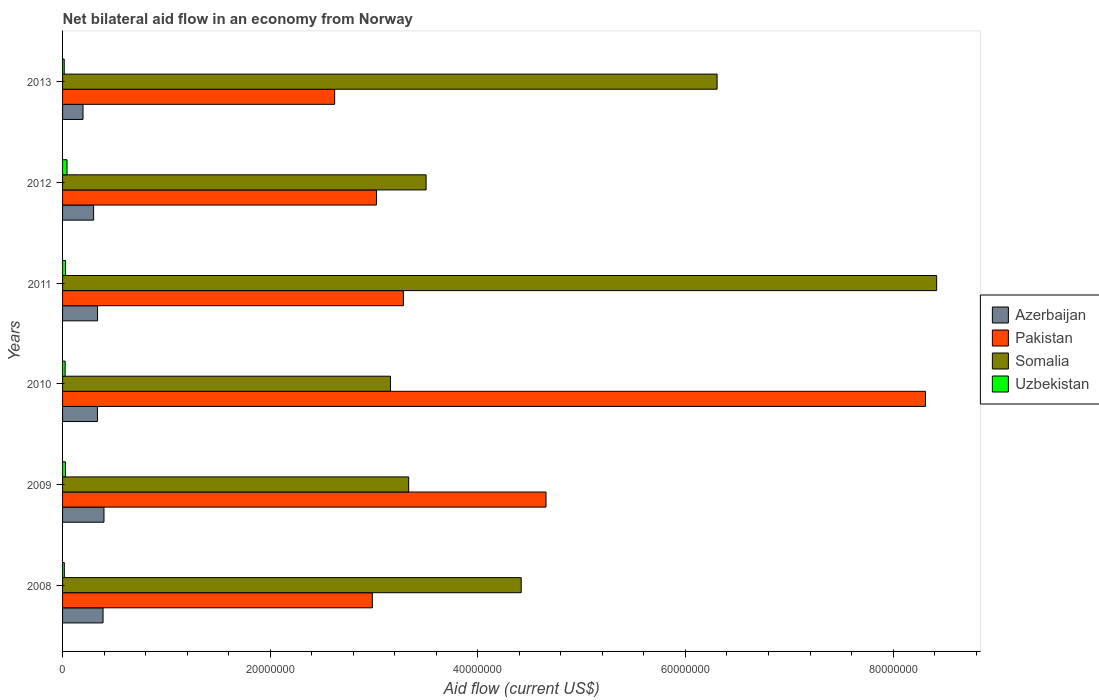Are the number of bars per tick equal to the number of legend labels?
Provide a short and direct response. Yes. What is the label of the 5th group of bars from the top?
Offer a very short reply. 2009. In how many cases, is the number of bars for a given year not equal to the number of legend labels?
Your answer should be compact. 0. Across all years, what is the maximum net bilateral aid flow in Uzbekistan?
Offer a very short reply. 4.30e+05. Across all years, what is the minimum net bilateral aid flow in Somalia?
Give a very brief answer. 3.16e+07. In which year was the net bilateral aid flow in Pakistan maximum?
Keep it short and to the point. 2010. What is the total net bilateral aid flow in Somalia in the graph?
Provide a succinct answer. 2.91e+08. What is the difference between the net bilateral aid flow in Uzbekistan in 2008 and that in 2013?
Keep it short and to the point. 10000. What is the difference between the net bilateral aid flow in Somalia in 2010 and the net bilateral aid flow in Azerbaijan in 2012?
Keep it short and to the point. 2.86e+07. What is the average net bilateral aid flow in Somalia per year?
Make the answer very short. 4.86e+07. In the year 2013, what is the difference between the net bilateral aid flow in Uzbekistan and net bilateral aid flow in Somalia?
Your response must be concise. -6.29e+07. In how many years, is the net bilateral aid flow in Pakistan greater than 36000000 US$?
Your answer should be very brief. 2. What is the ratio of the net bilateral aid flow in Azerbaijan in 2010 to that in 2011?
Offer a very short reply. 1. Is the net bilateral aid flow in Somalia in 2010 less than that in 2012?
Your answer should be compact. Yes. Is the difference between the net bilateral aid flow in Uzbekistan in 2008 and 2010 greater than the difference between the net bilateral aid flow in Somalia in 2008 and 2010?
Give a very brief answer. No. What is the difference between the highest and the second highest net bilateral aid flow in Pakistan?
Make the answer very short. 3.66e+07. What is the difference between the highest and the lowest net bilateral aid flow in Somalia?
Your answer should be very brief. 5.26e+07. In how many years, is the net bilateral aid flow in Somalia greater than the average net bilateral aid flow in Somalia taken over all years?
Ensure brevity in your answer.  2. What does the 1st bar from the top in 2011 represents?
Ensure brevity in your answer.  Uzbekistan. What does the 2nd bar from the bottom in 2011 represents?
Keep it short and to the point. Pakistan. How many bars are there?
Keep it short and to the point. 24. Are the values on the major ticks of X-axis written in scientific E-notation?
Your answer should be very brief. No. Does the graph contain grids?
Your answer should be compact. No. How many legend labels are there?
Make the answer very short. 4. What is the title of the graph?
Make the answer very short. Net bilateral aid flow in an economy from Norway. What is the label or title of the Y-axis?
Offer a very short reply. Years. What is the Aid flow (current US$) of Azerbaijan in 2008?
Your answer should be very brief. 3.90e+06. What is the Aid flow (current US$) of Pakistan in 2008?
Your answer should be very brief. 2.98e+07. What is the Aid flow (current US$) of Somalia in 2008?
Offer a terse response. 4.42e+07. What is the Aid flow (current US$) of Uzbekistan in 2008?
Ensure brevity in your answer.  1.70e+05. What is the Aid flow (current US$) of Azerbaijan in 2009?
Provide a succinct answer. 3.99e+06. What is the Aid flow (current US$) in Pakistan in 2009?
Provide a short and direct response. 4.66e+07. What is the Aid flow (current US$) of Somalia in 2009?
Provide a succinct answer. 3.33e+07. What is the Aid flow (current US$) of Uzbekistan in 2009?
Make the answer very short. 2.80e+05. What is the Aid flow (current US$) of Azerbaijan in 2010?
Your response must be concise. 3.36e+06. What is the Aid flow (current US$) of Pakistan in 2010?
Provide a succinct answer. 8.31e+07. What is the Aid flow (current US$) in Somalia in 2010?
Your answer should be compact. 3.16e+07. What is the Aid flow (current US$) in Azerbaijan in 2011?
Offer a very short reply. 3.37e+06. What is the Aid flow (current US$) of Pakistan in 2011?
Your response must be concise. 3.28e+07. What is the Aid flow (current US$) in Somalia in 2011?
Offer a terse response. 8.42e+07. What is the Aid flow (current US$) in Azerbaijan in 2012?
Your answer should be compact. 2.99e+06. What is the Aid flow (current US$) in Pakistan in 2012?
Keep it short and to the point. 3.02e+07. What is the Aid flow (current US$) of Somalia in 2012?
Keep it short and to the point. 3.50e+07. What is the Aid flow (current US$) of Uzbekistan in 2012?
Give a very brief answer. 4.30e+05. What is the Aid flow (current US$) of Azerbaijan in 2013?
Give a very brief answer. 1.97e+06. What is the Aid flow (current US$) in Pakistan in 2013?
Give a very brief answer. 2.62e+07. What is the Aid flow (current US$) in Somalia in 2013?
Ensure brevity in your answer.  6.30e+07. Across all years, what is the maximum Aid flow (current US$) in Azerbaijan?
Give a very brief answer. 3.99e+06. Across all years, what is the maximum Aid flow (current US$) in Pakistan?
Offer a very short reply. 8.31e+07. Across all years, what is the maximum Aid flow (current US$) of Somalia?
Provide a short and direct response. 8.42e+07. Across all years, what is the maximum Aid flow (current US$) in Uzbekistan?
Your response must be concise. 4.30e+05. Across all years, what is the minimum Aid flow (current US$) of Azerbaijan?
Provide a succinct answer. 1.97e+06. Across all years, what is the minimum Aid flow (current US$) of Pakistan?
Your answer should be compact. 2.62e+07. Across all years, what is the minimum Aid flow (current US$) of Somalia?
Ensure brevity in your answer.  3.16e+07. Across all years, what is the minimum Aid flow (current US$) in Uzbekistan?
Provide a short and direct response. 1.60e+05. What is the total Aid flow (current US$) in Azerbaijan in the graph?
Give a very brief answer. 1.96e+07. What is the total Aid flow (current US$) of Pakistan in the graph?
Your answer should be compact. 2.49e+08. What is the total Aid flow (current US$) in Somalia in the graph?
Keep it short and to the point. 2.91e+08. What is the total Aid flow (current US$) of Uzbekistan in the graph?
Offer a very short reply. 1.58e+06. What is the difference between the Aid flow (current US$) in Pakistan in 2008 and that in 2009?
Ensure brevity in your answer.  -1.67e+07. What is the difference between the Aid flow (current US$) in Somalia in 2008 and that in 2009?
Keep it short and to the point. 1.08e+07. What is the difference between the Aid flow (current US$) in Azerbaijan in 2008 and that in 2010?
Provide a succinct answer. 5.40e+05. What is the difference between the Aid flow (current US$) of Pakistan in 2008 and that in 2010?
Provide a succinct answer. -5.33e+07. What is the difference between the Aid flow (current US$) of Somalia in 2008 and that in 2010?
Give a very brief answer. 1.26e+07. What is the difference between the Aid flow (current US$) of Azerbaijan in 2008 and that in 2011?
Provide a short and direct response. 5.30e+05. What is the difference between the Aid flow (current US$) of Pakistan in 2008 and that in 2011?
Provide a succinct answer. -2.99e+06. What is the difference between the Aid flow (current US$) of Somalia in 2008 and that in 2011?
Give a very brief answer. -4.00e+07. What is the difference between the Aid flow (current US$) of Azerbaijan in 2008 and that in 2012?
Make the answer very short. 9.10e+05. What is the difference between the Aid flow (current US$) of Pakistan in 2008 and that in 2012?
Give a very brief answer. -4.00e+05. What is the difference between the Aid flow (current US$) of Somalia in 2008 and that in 2012?
Make the answer very short. 9.16e+06. What is the difference between the Aid flow (current US$) of Uzbekistan in 2008 and that in 2012?
Keep it short and to the point. -2.60e+05. What is the difference between the Aid flow (current US$) of Azerbaijan in 2008 and that in 2013?
Ensure brevity in your answer.  1.93e+06. What is the difference between the Aid flow (current US$) in Pakistan in 2008 and that in 2013?
Keep it short and to the point. 3.63e+06. What is the difference between the Aid flow (current US$) of Somalia in 2008 and that in 2013?
Your response must be concise. -1.89e+07. What is the difference between the Aid flow (current US$) of Uzbekistan in 2008 and that in 2013?
Provide a short and direct response. 10000. What is the difference between the Aid flow (current US$) of Azerbaijan in 2009 and that in 2010?
Provide a short and direct response. 6.30e+05. What is the difference between the Aid flow (current US$) of Pakistan in 2009 and that in 2010?
Keep it short and to the point. -3.66e+07. What is the difference between the Aid flow (current US$) of Somalia in 2009 and that in 2010?
Make the answer very short. 1.75e+06. What is the difference between the Aid flow (current US$) in Uzbekistan in 2009 and that in 2010?
Make the answer very short. 3.00e+04. What is the difference between the Aid flow (current US$) in Azerbaijan in 2009 and that in 2011?
Give a very brief answer. 6.20e+05. What is the difference between the Aid flow (current US$) of Pakistan in 2009 and that in 2011?
Offer a terse response. 1.37e+07. What is the difference between the Aid flow (current US$) of Somalia in 2009 and that in 2011?
Keep it short and to the point. -5.09e+07. What is the difference between the Aid flow (current US$) in Azerbaijan in 2009 and that in 2012?
Offer a very short reply. 1.00e+06. What is the difference between the Aid flow (current US$) of Pakistan in 2009 and that in 2012?
Give a very brief answer. 1.63e+07. What is the difference between the Aid flow (current US$) in Somalia in 2009 and that in 2012?
Make the answer very short. -1.68e+06. What is the difference between the Aid flow (current US$) of Azerbaijan in 2009 and that in 2013?
Your answer should be compact. 2.02e+06. What is the difference between the Aid flow (current US$) of Pakistan in 2009 and that in 2013?
Your response must be concise. 2.04e+07. What is the difference between the Aid flow (current US$) in Somalia in 2009 and that in 2013?
Offer a terse response. -2.97e+07. What is the difference between the Aid flow (current US$) of Pakistan in 2010 and that in 2011?
Provide a short and direct response. 5.03e+07. What is the difference between the Aid flow (current US$) in Somalia in 2010 and that in 2011?
Give a very brief answer. -5.26e+07. What is the difference between the Aid flow (current US$) of Uzbekistan in 2010 and that in 2011?
Ensure brevity in your answer.  -4.00e+04. What is the difference between the Aid flow (current US$) of Azerbaijan in 2010 and that in 2012?
Keep it short and to the point. 3.70e+05. What is the difference between the Aid flow (current US$) of Pakistan in 2010 and that in 2012?
Make the answer very short. 5.29e+07. What is the difference between the Aid flow (current US$) of Somalia in 2010 and that in 2012?
Your answer should be very brief. -3.43e+06. What is the difference between the Aid flow (current US$) in Uzbekistan in 2010 and that in 2012?
Keep it short and to the point. -1.80e+05. What is the difference between the Aid flow (current US$) of Azerbaijan in 2010 and that in 2013?
Provide a succinct answer. 1.39e+06. What is the difference between the Aid flow (current US$) of Pakistan in 2010 and that in 2013?
Make the answer very short. 5.69e+07. What is the difference between the Aid flow (current US$) in Somalia in 2010 and that in 2013?
Your answer should be compact. -3.15e+07. What is the difference between the Aid flow (current US$) in Azerbaijan in 2011 and that in 2012?
Keep it short and to the point. 3.80e+05. What is the difference between the Aid flow (current US$) of Pakistan in 2011 and that in 2012?
Keep it short and to the point. 2.59e+06. What is the difference between the Aid flow (current US$) of Somalia in 2011 and that in 2012?
Make the answer very short. 4.92e+07. What is the difference between the Aid flow (current US$) in Uzbekistan in 2011 and that in 2012?
Provide a short and direct response. -1.40e+05. What is the difference between the Aid flow (current US$) in Azerbaijan in 2011 and that in 2013?
Provide a short and direct response. 1.40e+06. What is the difference between the Aid flow (current US$) of Pakistan in 2011 and that in 2013?
Make the answer very short. 6.62e+06. What is the difference between the Aid flow (current US$) of Somalia in 2011 and that in 2013?
Make the answer very short. 2.12e+07. What is the difference between the Aid flow (current US$) in Uzbekistan in 2011 and that in 2013?
Your response must be concise. 1.30e+05. What is the difference between the Aid flow (current US$) in Azerbaijan in 2012 and that in 2013?
Ensure brevity in your answer.  1.02e+06. What is the difference between the Aid flow (current US$) in Pakistan in 2012 and that in 2013?
Offer a very short reply. 4.03e+06. What is the difference between the Aid flow (current US$) in Somalia in 2012 and that in 2013?
Offer a terse response. -2.80e+07. What is the difference between the Aid flow (current US$) of Uzbekistan in 2012 and that in 2013?
Your answer should be very brief. 2.70e+05. What is the difference between the Aid flow (current US$) in Azerbaijan in 2008 and the Aid flow (current US$) in Pakistan in 2009?
Offer a terse response. -4.27e+07. What is the difference between the Aid flow (current US$) in Azerbaijan in 2008 and the Aid flow (current US$) in Somalia in 2009?
Make the answer very short. -2.94e+07. What is the difference between the Aid flow (current US$) in Azerbaijan in 2008 and the Aid flow (current US$) in Uzbekistan in 2009?
Keep it short and to the point. 3.62e+06. What is the difference between the Aid flow (current US$) of Pakistan in 2008 and the Aid flow (current US$) of Somalia in 2009?
Provide a succinct answer. -3.50e+06. What is the difference between the Aid flow (current US$) of Pakistan in 2008 and the Aid flow (current US$) of Uzbekistan in 2009?
Make the answer very short. 2.96e+07. What is the difference between the Aid flow (current US$) of Somalia in 2008 and the Aid flow (current US$) of Uzbekistan in 2009?
Give a very brief answer. 4.39e+07. What is the difference between the Aid flow (current US$) in Azerbaijan in 2008 and the Aid flow (current US$) in Pakistan in 2010?
Give a very brief answer. -7.92e+07. What is the difference between the Aid flow (current US$) of Azerbaijan in 2008 and the Aid flow (current US$) of Somalia in 2010?
Keep it short and to the point. -2.77e+07. What is the difference between the Aid flow (current US$) in Azerbaijan in 2008 and the Aid flow (current US$) in Uzbekistan in 2010?
Provide a succinct answer. 3.65e+06. What is the difference between the Aid flow (current US$) of Pakistan in 2008 and the Aid flow (current US$) of Somalia in 2010?
Offer a terse response. -1.75e+06. What is the difference between the Aid flow (current US$) of Pakistan in 2008 and the Aid flow (current US$) of Uzbekistan in 2010?
Provide a succinct answer. 2.96e+07. What is the difference between the Aid flow (current US$) in Somalia in 2008 and the Aid flow (current US$) in Uzbekistan in 2010?
Your answer should be very brief. 4.39e+07. What is the difference between the Aid flow (current US$) of Azerbaijan in 2008 and the Aid flow (current US$) of Pakistan in 2011?
Your answer should be compact. -2.89e+07. What is the difference between the Aid flow (current US$) in Azerbaijan in 2008 and the Aid flow (current US$) in Somalia in 2011?
Your response must be concise. -8.03e+07. What is the difference between the Aid flow (current US$) of Azerbaijan in 2008 and the Aid flow (current US$) of Uzbekistan in 2011?
Offer a very short reply. 3.61e+06. What is the difference between the Aid flow (current US$) of Pakistan in 2008 and the Aid flow (current US$) of Somalia in 2011?
Keep it short and to the point. -5.44e+07. What is the difference between the Aid flow (current US$) of Pakistan in 2008 and the Aid flow (current US$) of Uzbekistan in 2011?
Make the answer very short. 2.96e+07. What is the difference between the Aid flow (current US$) of Somalia in 2008 and the Aid flow (current US$) of Uzbekistan in 2011?
Offer a very short reply. 4.39e+07. What is the difference between the Aid flow (current US$) of Azerbaijan in 2008 and the Aid flow (current US$) of Pakistan in 2012?
Ensure brevity in your answer.  -2.63e+07. What is the difference between the Aid flow (current US$) in Azerbaijan in 2008 and the Aid flow (current US$) in Somalia in 2012?
Offer a very short reply. -3.11e+07. What is the difference between the Aid flow (current US$) in Azerbaijan in 2008 and the Aid flow (current US$) in Uzbekistan in 2012?
Keep it short and to the point. 3.47e+06. What is the difference between the Aid flow (current US$) of Pakistan in 2008 and the Aid flow (current US$) of Somalia in 2012?
Make the answer very short. -5.18e+06. What is the difference between the Aid flow (current US$) in Pakistan in 2008 and the Aid flow (current US$) in Uzbekistan in 2012?
Make the answer very short. 2.94e+07. What is the difference between the Aid flow (current US$) in Somalia in 2008 and the Aid flow (current US$) in Uzbekistan in 2012?
Offer a terse response. 4.38e+07. What is the difference between the Aid flow (current US$) of Azerbaijan in 2008 and the Aid flow (current US$) of Pakistan in 2013?
Provide a short and direct response. -2.23e+07. What is the difference between the Aid flow (current US$) of Azerbaijan in 2008 and the Aid flow (current US$) of Somalia in 2013?
Keep it short and to the point. -5.92e+07. What is the difference between the Aid flow (current US$) in Azerbaijan in 2008 and the Aid flow (current US$) in Uzbekistan in 2013?
Offer a terse response. 3.74e+06. What is the difference between the Aid flow (current US$) in Pakistan in 2008 and the Aid flow (current US$) in Somalia in 2013?
Give a very brief answer. -3.32e+07. What is the difference between the Aid flow (current US$) of Pakistan in 2008 and the Aid flow (current US$) of Uzbekistan in 2013?
Provide a succinct answer. 2.97e+07. What is the difference between the Aid flow (current US$) in Somalia in 2008 and the Aid flow (current US$) in Uzbekistan in 2013?
Your response must be concise. 4.40e+07. What is the difference between the Aid flow (current US$) of Azerbaijan in 2009 and the Aid flow (current US$) of Pakistan in 2010?
Keep it short and to the point. -7.91e+07. What is the difference between the Aid flow (current US$) in Azerbaijan in 2009 and the Aid flow (current US$) in Somalia in 2010?
Make the answer very short. -2.76e+07. What is the difference between the Aid flow (current US$) in Azerbaijan in 2009 and the Aid flow (current US$) in Uzbekistan in 2010?
Make the answer very short. 3.74e+06. What is the difference between the Aid flow (current US$) in Pakistan in 2009 and the Aid flow (current US$) in Somalia in 2010?
Provide a short and direct response. 1.50e+07. What is the difference between the Aid flow (current US$) in Pakistan in 2009 and the Aid flow (current US$) in Uzbekistan in 2010?
Offer a very short reply. 4.63e+07. What is the difference between the Aid flow (current US$) of Somalia in 2009 and the Aid flow (current US$) of Uzbekistan in 2010?
Keep it short and to the point. 3.31e+07. What is the difference between the Aid flow (current US$) of Azerbaijan in 2009 and the Aid flow (current US$) of Pakistan in 2011?
Offer a terse response. -2.88e+07. What is the difference between the Aid flow (current US$) in Azerbaijan in 2009 and the Aid flow (current US$) in Somalia in 2011?
Your answer should be very brief. -8.02e+07. What is the difference between the Aid flow (current US$) in Azerbaijan in 2009 and the Aid flow (current US$) in Uzbekistan in 2011?
Ensure brevity in your answer.  3.70e+06. What is the difference between the Aid flow (current US$) in Pakistan in 2009 and the Aid flow (current US$) in Somalia in 2011?
Offer a very short reply. -3.76e+07. What is the difference between the Aid flow (current US$) of Pakistan in 2009 and the Aid flow (current US$) of Uzbekistan in 2011?
Offer a terse response. 4.63e+07. What is the difference between the Aid flow (current US$) of Somalia in 2009 and the Aid flow (current US$) of Uzbekistan in 2011?
Provide a succinct answer. 3.30e+07. What is the difference between the Aid flow (current US$) in Azerbaijan in 2009 and the Aid flow (current US$) in Pakistan in 2012?
Give a very brief answer. -2.62e+07. What is the difference between the Aid flow (current US$) of Azerbaijan in 2009 and the Aid flow (current US$) of Somalia in 2012?
Ensure brevity in your answer.  -3.10e+07. What is the difference between the Aid flow (current US$) of Azerbaijan in 2009 and the Aid flow (current US$) of Uzbekistan in 2012?
Offer a terse response. 3.56e+06. What is the difference between the Aid flow (current US$) in Pakistan in 2009 and the Aid flow (current US$) in Somalia in 2012?
Make the answer very short. 1.16e+07. What is the difference between the Aid flow (current US$) of Pakistan in 2009 and the Aid flow (current US$) of Uzbekistan in 2012?
Offer a terse response. 4.61e+07. What is the difference between the Aid flow (current US$) of Somalia in 2009 and the Aid flow (current US$) of Uzbekistan in 2012?
Provide a succinct answer. 3.29e+07. What is the difference between the Aid flow (current US$) in Azerbaijan in 2009 and the Aid flow (current US$) in Pakistan in 2013?
Your answer should be very brief. -2.22e+07. What is the difference between the Aid flow (current US$) of Azerbaijan in 2009 and the Aid flow (current US$) of Somalia in 2013?
Ensure brevity in your answer.  -5.91e+07. What is the difference between the Aid flow (current US$) in Azerbaijan in 2009 and the Aid flow (current US$) in Uzbekistan in 2013?
Provide a succinct answer. 3.83e+06. What is the difference between the Aid flow (current US$) in Pakistan in 2009 and the Aid flow (current US$) in Somalia in 2013?
Your answer should be very brief. -1.65e+07. What is the difference between the Aid flow (current US$) of Pakistan in 2009 and the Aid flow (current US$) of Uzbekistan in 2013?
Ensure brevity in your answer.  4.64e+07. What is the difference between the Aid flow (current US$) in Somalia in 2009 and the Aid flow (current US$) in Uzbekistan in 2013?
Ensure brevity in your answer.  3.32e+07. What is the difference between the Aid flow (current US$) of Azerbaijan in 2010 and the Aid flow (current US$) of Pakistan in 2011?
Offer a very short reply. -2.95e+07. What is the difference between the Aid flow (current US$) in Azerbaijan in 2010 and the Aid flow (current US$) in Somalia in 2011?
Ensure brevity in your answer.  -8.08e+07. What is the difference between the Aid flow (current US$) in Azerbaijan in 2010 and the Aid flow (current US$) in Uzbekistan in 2011?
Provide a succinct answer. 3.07e+06. What is the difference between the Aid flow (current US$) of Pakistan in 2010 and the Aid flow (current US$) of Somalia in 2011?
Provide a succinct answer. -1.08e+06. What is the difference between the Aid flow (current US$) of Pakistan in 2010 and the Aid flow (current US$) of Uzbekistan in 2011?
Provide a short and direct response. 8.28e+07. What is the difference between the Aid flow (current US$) in Somalia in 2010 and the Aid flow (current US$) in Uzbekistan in 2011?
Give a very brief answer. 3.13e+07. What is the difference between the Aid flow (current US$) of Azerbaijan in 2010 and the Aid flow (current US$) of Pakistan in 2012?
Make the answer very short. -2.69e+07. What is the difference between the Aid flow (current US$) of Azerbaijan in 2010 and the Aid flow (current US$) of Somalia in 2012?
Provide a short and direct response. -3.17e+07. What is the difference between the Aid flow (current US$) of Azerbaijan in 2010 and the Aid flow (current US$) of Uzbekistan in 2012?
Offer a very short reply. 2.93e+06. What is the difference between the Aid flow (current US$) in Pakistan in 2010 and the Aid flow (current US$) in Somalia in 2012?
Your response must be concise. 4.81e+07. What is the difference between the Aid flow (current US$) in Pakistan in 2010 and the Aid flow (current US$) in Uzbekistan in 2012?
Your response must be concise. 8.27e+07. What is the difference between the Aid flow (current US$) in Somalia in 2010 and the Aid flow (current US$) in Uzbekistan in 2012?
Your response must be concise. 3.12e+07. What is the difference between the Aid flow (current US$) in Azerbaijan in 2010 and the Aid flow (current US$) in Pakistan in 2013?
Give a very brief answer. -2.28e+07. What is the difference between the Aid flow (current US$) of Azerbaijan in 2010 and the Aid flow (current US$) of Somalia in 2013?
Offer a terse response. -5.97e+07. What is the difference between the Aid flow (current US$) in Azerbaijan in 2010 and the Aid flow (current US$) in Uzbekistan in 2013?
Your answer should be compact. 3.20e+06. What is the difference between the Aid flow (current US$) in Pakistan in 2010 and the Aid flow (current US$) in Somalia in 2013?
Provide a succinct answer. 2.01e+07. What is the difference between the Aid flow (current US$) of Pakistan in 2010 and the Aid flow (current US$) of Uzbekistan in 2013?
Ensure brevity in your answer.  8.30e+07. What is the difference between the Aid flow (current US$) of Somalia in 2010 and the Aid flow (current US$) of Uzbekistan in 2013?
Offer a terse response. 3.14e+07. What is the difference between the Aid flow (current US$) in Azerbaijan in 2011 and the Aid flow (current US$) in Pakistan in 2012?
Your response must be concise. -2.69e+07. What is the difference between the Aid flow (current US$) of Azerbaijan in 2011 and the Aid flow (current US$) of Somalia in 2012?
Offer a terse response. -3.16e+07. What is the difference between the Aid flow (current US$) of Azerbaijan in 2011 and the Aid flow (current US$) of Uzbekistan in 2012?
Make the answer very short. 2.94e+06. What is the difference between the Aid flow (current US$) of Pakistan in 2011 and the Aid flow (current US$) of Somalia in 2012?
Your response must be concise. -2.19e+06. What is the difference between the Aid flow (current US$) in Pakistan in 2011 and the Aid flow (current US$) in Uzbekistan in 2012?
Provide a succinct answer. 3.24e+07. What is the difference between the Aid flow (current US$) in Somalia in 2011 and the Aid flow (current US$) in Uzbekistan in 2012?
Make the answer very short. 8.38e+07. What is the difference between the Aid flow (current US$) in Azerbaijan in 2011 and the Aid flow (current US$) in Pakistan in 2013?
Your response must be concise. -2.28e+07. What is the difference between the Aid flow (current US$) in Azerbaijan in 2011 and the Aid flow (current US$) in Somalia in 2013?
Give a very brief answer. -5.97e+07. What is the difference between the Aid flow (current US$) of Azerbaijan in 2011 and the Aid flow (current US$) of Uzbekistan in 2013?
Ensure brevity in your answer.  3.21e+06. What is the difference between the Aid flow (current US$) of Pakistan in 2011 and the Aid flow (current US$) of Somalia in 2013?
Your response must be concise. -3.02e+07. What is the difference between the Aid flow (current US$) in Pakistan in 2011 and the Aid flow (current US$) in Uzbekistan in 2013?
Give a very brief answer. 3.27e+07. What is the difference between the Aid flow (current US$) of Somalia in 2011 and the Aid flow (current US$) of Uzbekistan in 2013?
Ensure brevity in your answer.  8.40e+07. What is the difference between the Aid flow (current US$) of Azerbaijan in 2012 and the Aid flow (current US$) of Pakistan in 2013?
Offer a terse response. -2.32e+07. What is the difference between the Aid flow (current US$) of Azerbaijan in 2012 and the Aid flow (current US$) of Somalia in 2013?
Provide a succinct answer. -6.01e+07. What is the difference between the Aid flow (current US$) of Azerbaijan in 2012 and the Aid flow (current US$) of Uzbekistan in 2013?
Provide a short and direct response. 2.83e+06. What is the difference between the Aid flow (current US$) in Pakistan in 2012 and the Aid flow (current US$) in Somalia in 2013?
Offer a terse response. -3.28e+07. What is the difference between the Aid flow (current US$) in Pakistan in 2012 and the Aid flow (current US$) in Uzbekistan in 2013?
Keep it short and to the point. 3.01e+07. What is the difference between the Aid flow (current US$) of Somalia in 2012 and the Aid flow (current US$) of Uzbekistan in 2013?
Give a very brief answer. 3.49e+07. What is the average Aid flow (current US$) of Azerbaijan per year?
Provide a short and direct response. 3.26e+06. What is the average Aid flow (current US$) in Pakistan per year?
Offer a very short reply. 4.15e+07. What is the average Aid flow (current US$) in Somalia per year?
Provide a short and direct response. 4.86e+07. What is the average Aid flow (current US$) of Uzbekistan per year?
Your response must be concise. 2.63e+05. In the year 2008, what is the difference between the Aid flow (current US$) in Azerbaijan and Aid flow (current US$) in Pakistan?
Make the answer very short. -2.59e+07. In the year 2008, what is the difference between the Aid flow (current US$) in Azerbaijan and Aid flow (current US$) in Somalia?
Provide a succinct answer. -4.03e+07. In the year 2008, what is the difference between the Aid flow (current US$) of Azerbaijan and Aid flow (current US$) of Uzbekistan?
Make the answer very short. 3.73e+06. In the year 2008, what is the difference between the Aid flow (current US$) of Pakistan and Aid flow (current US$) of Somalia?
Provide a short and direct response. -1.43e+07. In the year 2008, what is the difference between the Aid flow (current US$) in Pakistan and Aid flow (current US$) in Uzbekistan?
Keep it short and to the point. 2.97e+07. In the year 2008, what is the difference between the Aid flow (current US$) in Somalia and Aid flow (current US$) in Uzbekistan?
Ensure brevity in your answer.  4.40e+07. In the year 2009, what is the difference between the Aid flow (current US$) of Azerbaijan and Aid flow (current US$) of Pakistan?
Ensure brevity in your answer.  -4.26e+07. In the year 2009, what is the difference between the Aid flow (current US$) in Azerbaijan and Aid flow (current US$) in Somalia?
Provide a short and direct response. -2.94e+07. In the year 2009, what is the difference between the Aid flow (current US$) of Azerbaijan and Aid flow (current US$) of Uzbekistan?
Your response must be concise. 3.71e+06. In the year 2009, what is the difference between the Aid flow (current US$) of Pakistan and Aid flow (current US$) of Somalia?
Make the answer very short. 1.32e+07. In the year 2009, what is the difference between the Aid flow (current US$) in Pakistan and Aid flow (current US$) in Uzbekistan?
Offer a very short reply. 4.63e+07. In the year 2009, what is the difference between the Aid flow (current US$) in Somalia and Aid flow (current US$) in Uzbekistan?
Offer a terse response. 3.31e+07. In the year 2010, what is the difference between the Aid flow (current US$) in Azerbaijan and Aid flow (current US$) in Pakistan?
Ensure brevity in your answer.  -7.98e+07. In the year 2010, what is the difference between the Aid flow (current US$) of Azerbaijan and Aid flow (current US$) of Somalia?
Provide a succinct answer. -2.82e+07. In the year 2010, what is the difference between the Aid flow (current US$) of Azerbaijan and Aid flow (current US$) of Uzbekistan?
Make the answer very short. 3.11e+06. In the year 2010, what is the difference between the Aid flow (current US$) of Pakistan and Aid flow (current US$) of Somalia?
Offer a very short reply. 5.15e+07. In the year 2010, what is the difference between the Aid flow (current US$) of Pakistan and Aid flow (current US$) of Uzbekistan?
Provide a short and direct response. 8.29e+07. In the year 2010, what is the difference between the Aid flow (current US$) in Somalia and Aid flow (current US$) in Uzbekistan?
Your response must be concise. 3.13e+07. In the year 2011, what is the difference between the Aid flow (current US$) of Azerbaijan and Aid flow (current US$) of Pakistan?
Offer a very short reply. -2.95e+07. In the year 2011, what is the difference between the Aid flow (current US$) of Azerbaijan and Aid flow (current US$) of Somalia?
Offer a very short reply. -8.08e+07. In the year 2011, what is the difference between the Aid flow (current US$) of Azerbaijan and Aid flow (current US$) of Uzbekistan?
Offer a very short reply. 3.08e+06. In the year 2011, what is the difference between the Aid flow (current US$) in Pakistan and Aid flow (current US$) in Somalia?
Offer a very short reply. -5.14e+07. In the year 2011, what is the difference between the Aid flow (current US$) of Pakistan and Aid flow (current US$) of Uzbekistan?
Give a very brief answer. 3.25e+07. In the year 2011, what is the difference between the Aid flow (current US$) in Somalia and Aid flow (current US$) in Uzbekistan?
Your answer should be compact. 8.39e+07. In the year 2012, what is the difference between the Aid flow (current US$) in Azerbaijan and Aid flow (current US$) in Pakistan?
Ensure brevity in your answer.  -2.72e+07. In the year 2012, what is the difference between the Aid flow (current US$) of Azerbaijan and Aid flow (current US$) of Somalia?
Your response must be concise. -3.20e+07. In the year 2012, what is the difference between the Aid flow (current US$) of Azerbaijan and Aid flow (current US$) of Uzbekistan?
Provide a short and direct response. 2.56e+06. In the year 2012, what is the difference between the Aid flow (current US$) in Pakistan and Aid flow (current US$) in Somalia?
Offer a terse response. -4.78e+06. In the year 2012, what is the difference between the Aid flow (current US$) of Pakistan and Aid flow (current US$) of Uzbekistan?
Provide a succinct answer. 2.98e+07. In the year 2012, what is the difference between the Aid flow (current US$) in Somalia and Aid flow (current US$) in Uzbekistan?
Provide a short and direct response. 3.46e+07. In the year 2013, what is the difference between the Aid flow (current US$) in Azerbaijan and Aid flow (current US$) in Pakistan?
Give a very brief answer. -2.42e+07. In the year 2013, what is the difference between the Aid flow (current US$) of Azerbaijan and Aid flow (current US$) of Somalia?
Offer a very short reply. -6.11e+07. In the year 2013, what is the difference between the Aid flow (current US$) of Azerbaijan and Aid flow (current US$) of Uzbekistan?
Ensure brevity in your answer.  1.81e+06. In the year 2013, what is the difference between the Aid flow (current US$) in Pakistan and Aid flow (current US$) in Somalia?
Make the answer very short. -3.68e+07. In the year 2013, what is the difference between the Aid flow (current US$) of Pakistan and Aid flow (current US$) of Uzbekistan?
Offer a terse response. 2.60e+07. In the year 2013, what is the difference between the Aid flow (current US$) of Somalia and Aid flow (current US$) of Uzbekistan?
Offer a very short reply. 6.29e+07. What is the ratio of the Aid flow (current US$) in Azerbaijan in 2008 to that in 2009?
Provide a short and direct response. 0.98. What is the ratio of the Aid flow (current US$) of Pakistan in 2008 to that in 2009?
Your answer should be compact. 0.64. What is the ratio of the Aid flow (current US$) in Somalia in 2008 to that in 2009?
Your response must be concise. 1.33. What is the ratio of the Aid flow (current US$) in Uzbekistan in 2008 to that in 2009?
Ensure brevity in your answer.  0.61. What is the ratio of the Aid flow (current US$) of Azerbaijan in 2008 to that in 2010?
Keep it short and to the point. 1.16. What is the ratio of the Aid flow (current US$) in Pakistan in 2008 to that in 2010?
Give a very brief answer. 0.36. What is the ratio of the Aid flow (current US$) in Somalia in 2008 to that in 2010?
Keep it short and to the point. 1.4. What is the ratio of the Aid flow (current US$) in Uzbekistan in 2008 to that in 2010?
Give a very brief answer. 0.68. What is the ratio of the Aid flow (current US$) in Azerbaijan in 2008 to that in 2011?
Your response must be concise. 1.16. What is the ratio of the Aid flow (current US$) of Pakistan in 2008 to that in 2011?
Make the answer very short. 0.91. What is the ratio of the Aid flow (current US$) of Somalia in 2008 to that in 2011?
Give a very brief answer. 0.52. What is the ratio of the Aid flow (current US$) in Uzbekistan in 2008 to that in 2011?
Provide a short and direct response. 0.59. What is the ratio of the Aid flow (current US$) in Azerbaijan in 2008 to that in 2012?
Your answer should be compact. 1.3. What is the ratio of the Aid flow (current US$) of Somalia in 2008 to that in 2012?
Keep it short and to the point. 1.26. What is the ratio of the Aid flow (current US$) in Uzbekistan in 2008 to that in 2012?
Provide a succinct answer. 0.4. What is the ratio of the Aid flow (current US$) of Azerbaijan in 2008 to that in 2013?
Your answer should be very brief. 1.98. What is the ratio of the Aid flow (current US$) in Pakistan in 2008 to that in 2013?
Your answer should be very brief. 1.14. What is the ratio of the Aid flow (current US$) of Somalia in 2008 to that in 2013?
Ensure brevity in your answer.  0.7. What is the ratio of the Aid flow (current US$) of Uzbekistan in 2008 to that in 2013?
Provide a succinct answer. 1.06. What is the ratio of the Aid flow (current US$) of Azerbaijan in 2009 to that in 2010?
Your response must be concise. 1.19. What is the ratio of the Aid flow (current US$) of Pakistan in 2009 to that in 2010?
Keep it short and to the point. 0.56. What is the ratio of the Aid flow (current US$) of Somalia in 2009 to that in 2010?
Ensure brevity in your answer.  1.06. What is the ratio of the Aid flow (current US$) in Uzbekistan in 2009 to that in 2010?
Make the answer very short. 1.12. What is the ratio of the Aid flow (current US$) of Azerbaijan in 2009 to that in 2011?
Provide a succinct answer. 1.18. What is the ratio of the Aid flow (current US$) in Pakistan in 2009 to that in 2011?
Provide a succinct answer. 1.42. What is the ratio of the Aid flow (current US$) of Somalia in 2009 to that in 2011?
Your answer should be very brief. 0.4. What is the ratio of the Aid flow (current US$) of Uzbekistan in 2009 to that in 2011?
Your answer should be very brief. 0.97. What is the ratio of the Aid flow (current US$) of Azerbaijan in 2009 to that in 2012?
Give a very brief answer. 1.33. What is the ratio of the Aid flow (current US$) of Pakistan in 2009 to that in 2012?
Keep it short and to the point. 1.54. What is the ratio of the Aid flow (current US$) in Uzbekistan in 2009 to that in 2012?
Offer a terse response. 0.65. What is the ratio of the Aid flow (current US$) in Azerbaijan in 2009 to that in 2013?
Keep it short and to the point. 2.03. What is the ratio of the Aid flow (current US$) in Pakistan in 2009 to that in 2013?
Give a very brief answer. 1.78. What is the ratio of the Aid flow (current US$) in Somalia in 2009 to that in 2013?
Provide a short and direct response. 0.53. What is the ratio of the Aid flow (current US$) in Pakistan in 2010 to that in 2011?
Give a very brief answer. 2.53. What is the ratio of the Aid flow (current US$) of Somalia in 2010 to that in 2011?
Give a very brief answer. 0.38. What is the ratio of the Aid flow (current US$) of Uzbekistan in 2010 to that in 2011?
Ensure brevity in your answer.  0.86. What is the ratio of the Aid flow (current US$) in Azerbaijan in 2010 to that in 2012?
Offer a terse response. 1.12. What is the ratio of the Aid flow (current US$) of Pakistan in 2010 to that in 2012?
Your response must be concise. 2.75. What is the ratio of the Aid flow (current US$) of Somalia in 2010 to that in 2012?
Provide a succinct answer. 0.9. What is the ratio of the Aid flow (current US$) in Uzbekistan in 2010 to that in 2012?
Your answer should be compact. 0.58. What is the ratio of the Aid flow (current US$) in Azerbaijan in 2010 to that in 2013?
Give a very brief answer. 1.71. What is the ratio of the Aid flow (current US$) of Pakistan in 2010 to that in 2013?
Offer a terse response. 3.17. What is the ratio of the Aid flow (current US$) in Somalia in 2010 to that in 2013?
Make the answer very short. 0.5. What is the ratio of the Aid flow (current US$) of Uzbekistan in 2010 to that in 2013?
Make the answer very short. 1.56. What is the ratio of the Aid flow (current US$) in Azerbaijan in 2011 to that in 2012?
Ensure brevity in your answer.  1.13. What is the ratio of the Aid flow (current US$) of Pakistan in 2011 to that in 2012?
Your answer should be very brief. 1.09. What is the ratio of the Aid flow (current US$) in Somalia in 2011 to that in 2012?
Offer a very short reply. 2.4. What is the ratio of the Aid flow (current US$) of Uzbekistan in 2011 to that in 2012?
Your answer should be compact. 0.67. What is the ratio of the Aid flow (current US$) in Azerbaijan in 2011 to that in 2013?
Your answer should be compact. 1.71. What is the ratio of the Aid flow (current US$) in Pakistan in 2011 to that in 2013?
Your answer should be compact. 1.25. What is the ratio of the Aid flow (current US$) in Somalia in 2011 to that in 2013?
Provide a short and direct response. 1.34. What is the ratio of the Aid flow (current US$) of Uzbekistan in 2011 to that in 2013?
Your response must be concise. 1.81. What is the ratio of the Aid flow (current US$) of Azerbaijan in 2012 to that in 2013?
Your response must be concise. 1.52. What is the ratio of the Aid flow (current US$) of Pakistan in 2012 to that in 2013?
Provide a short and direct response. 1.15. What is the ratio of the Aid flow (current US$) of Somalia in 2012 to that in 2013?
Give a very brief answer. 0.56. What is the ratio of the Aid flow (current US$) of Uzbekistan in 2012 to that in 2013?
Ensure brevity in your answer.  2.69. What is the difference between the highest and the second highest Aid flow (current US$) in Pakistan?
Offer a terse response. 3.66e+07. What is the difference between the highest and the second highest Aid flow (current US$) of Somalia?
Offer a very short reply. 2.12e+07. What is the difference between the highest and the lowest Aid flow (current US$) in Azerbaijan?
Provide a succinct answer. 2.02e+06. What is the difference between the highest and the lowest Aid flow (current US$) in Pakistan?
Your answer should be compact. 5.69e+07. What is the difference between the highest and the lowest Aid flow (current US$) of Somalia?
Make the answer very short. 5.26e+07. 